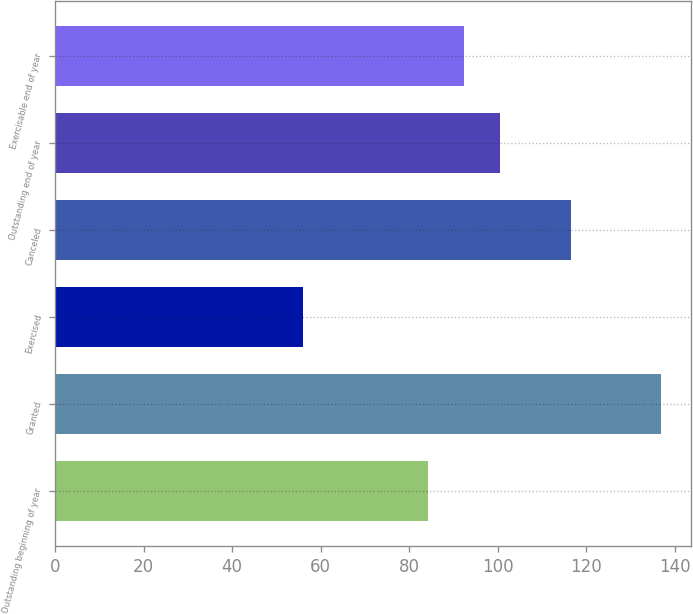Convert chart. <chart><loc_0><loc_0><loc_500><loc_500><bar_chart><fcel>Outstanding beginning of year<fcel>Granted<fcel>Exercised<fcel>Canceled<fcel>Outstanding end of year<fcel>Exercisable end of year<nl><fcel>84.22<fcel>136.87<fcel>56<fcel>116.44<fcel>100.4<fcel>92.31<nl></chart> 